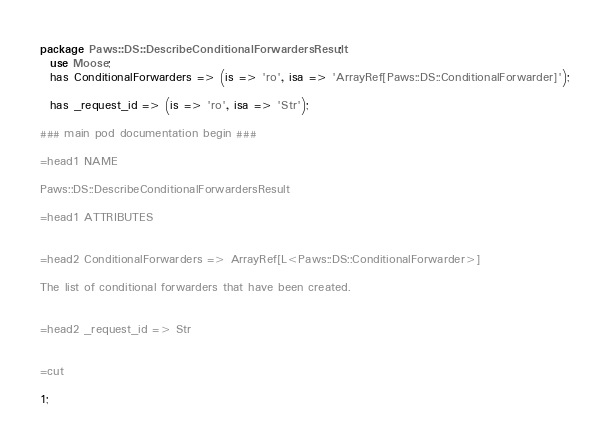Convert code to text. <code><loc_0><loc_0><loc_500><loc_500><_Perl_>
package Paws::DS::DescribeConditionalForwardersResult;
  use Moose;
  has ConditionalForwarders => (is => 'ro', isa => 'ArrayRef[Paws::DS::ConditionalForwarder]');

  has _request_id => (is => 'ro', isa => 'Str');

### main pod documentation begin ###

=head1 NAME

Paws::DS::DescribeConditionalForwardersResult

=head1 ATTRIBUTES


=head2 ConditionalForwarders => ArrayRef[L<Paws::DS::ConditionalForwarder>]

The list of conditional forwarders that have been created.


=head2 _request_id => Str


=cut

1;</code> 